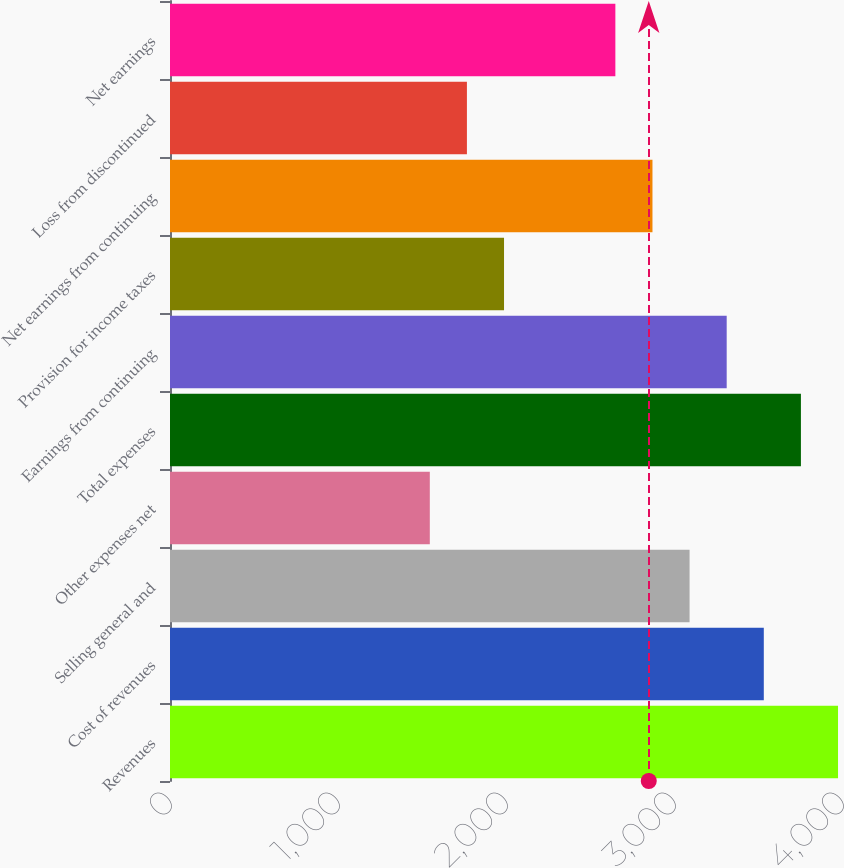<chart> <loc_0><loc_0><loc_500><loc_500><bar_chart><fcel>Revenues<fcel>Cost of revenues<fcel>Selling general and<fcel>Other expenses net<fcel>Total expenses<fcel>Earnings from continuing<fcel>Provision for income taxes<fcel>Net earnings from continuing<fcel>Loss from discontinued<fcel>Net earnings<nl><fcel>3976.34<fcel>3534.55<fcel>3092.76<fcel>1546.49<fcel>3755.45<fcel>3313.66<fcel>1988.28<fcel>2871.86<fcel>1767.38<fcel>2650.97<nl></chart> 